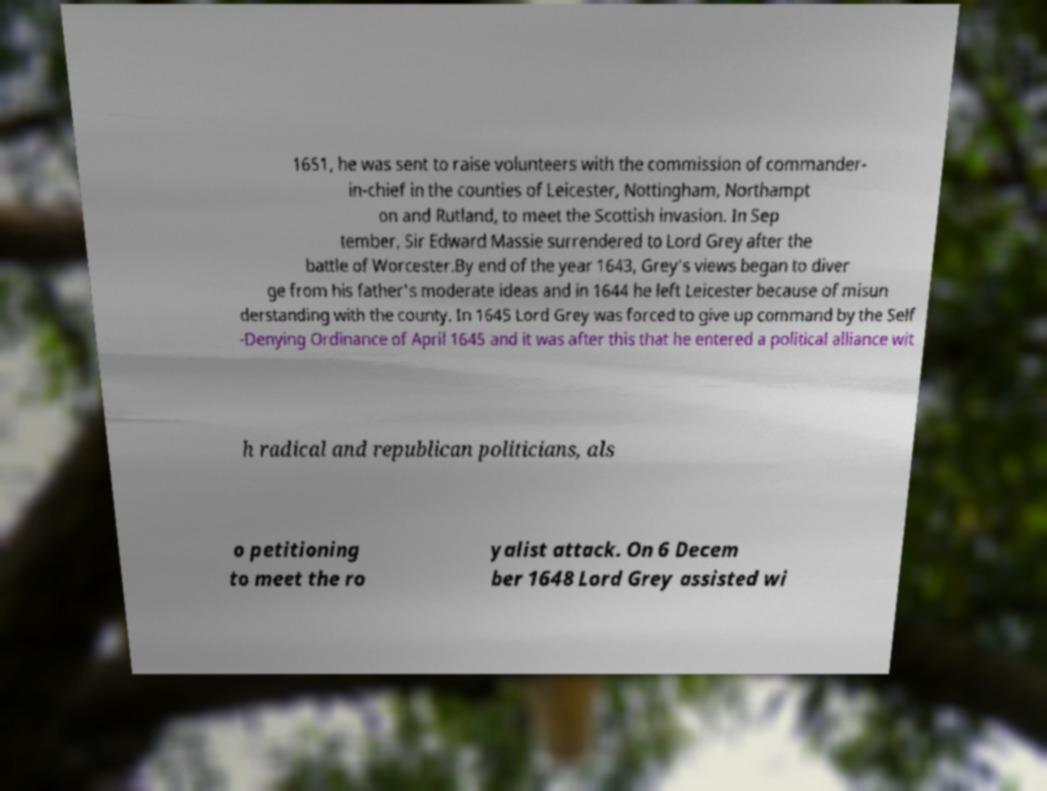Could you extract and type out the text from this image? 1651, he was sent to raise volunteers with the commission of commander- in-chief in the counties of Leicester, Nottingham, Northampt on and Rutland, to meet the Scottish invasion. In Sep tember, Sir Edward Massie surrendered to Lord Grey after the battle of Worcester.By end of the year 1643, Grey's views began to diver ge from his father's moderate ideas and in 1644 he left Leicester because of misun derstanding with the county. In 1645 Lord Grey was forced to give up command by the Self -Denying Ordinance of April 1645 and it was after this that he entered a political alliance wit h radical and republican politicians, als o petitioning to meet the ro yalist attack. On 6 Decem ber 1648 Lord Grey assisted wi 